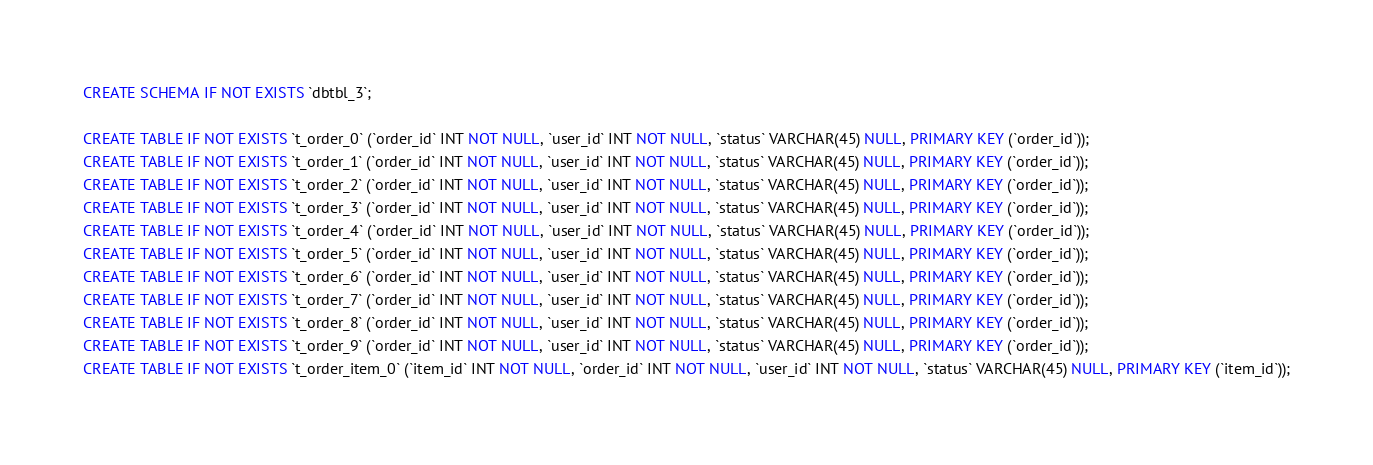Convert code to text. <code><loc_0><loc_0><loc_500><loc_500><_SQL_>CREATE SCHEMA IF NOT EXISTS `dbtbl_3`;

CREATE TABLE IF NOT EXISTS `t_order_0` (`order_id` INT NOT NULL, `user_id` INT NOT NULL, `status` VARCHAR(45) NULL, PRIMARY KEY (`order_id`));
CREATE TABLE IF NOT EXISTS `t_order_1` (`order_id` INT NOT NULL, `user_id` INT NOT NULL, `status` VARCHAR(45) NULL, PRIMARY KEY (`order_id`));
CREATE TABLE IF NOT EXISTS `t_order_2` (`order_id` INT NOT NULL, `user_id` INT NOT NULL, `status` VARCHAR(45) NULL, PRIMARY KEY (`order_id`));
CREATE TABLE IF NOT EXISTS `t_order_3` (`order_id` INT NOT NULL, `user_id` INT NOT NULL, `status` VARCHAR(45) NULL, PRIMARY KEY (`order_id`));
CREATE TABLE IF NOT EXISTS `t_order_4` (`order_id` INT NOT NULL, `user_id` INT NOT NULL, `status` VARCHAR(45) NULL, PRIMARY KEY (`order_id`));
CREATE TABLE IF NOT EXISTS `t_order_5` (`order_id` INT NOT NULL, `user_id` INT NOT NULL, `status` VARCHAR(45) NULL, PRIMARY KEY (`order_id`));
CREATE TABLE IF NOT EXISTS `t_order_6` (`order_id` INT NOT NULL, `user_id` INT NOT NULL, `status` VARCHAR(45) NULL, PRIMARY KEY (`order_id`));
CREATE TABLE IF NOT EXISTS `t_order_7` (`order_id` INT NOT NULL, `user_id` INT NOT NULL, `status` VARCHAR(45) NULL, PRIMARY KEY (`order_id`));
CREATE TABLE IF NOT EXISTS `t_order_8` (`order_id` INT NOT NULL, `user_id` INT NOT NULL, `status` VARCHAR(45) NULL, PRIMARY KEY (`order_id`));
CREATE TABLE IF NOT EXISTS `t_order_9` (`order_id` INT NOT NULL, `user_id` INT NOT NULL, `status` VARCHAR(45) NULL, PRIMARY KEY (`order_id`));
CREATE TABLE IF NOT EXISTS `t_order_item_0` (`item_id` INT NOT NULL, `order_id` INT NOT NULL, `user_id` INT NOT NULL, `status` VARCHAR(45) NULL, PRIMARY KEY (`item_id`));</code> 